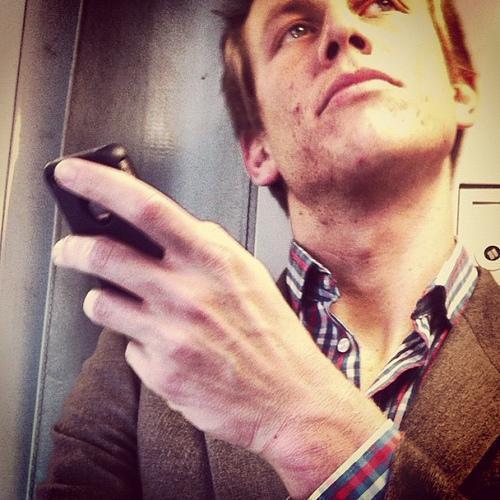How many people are in photo?
Give a very brief answer. 1. 